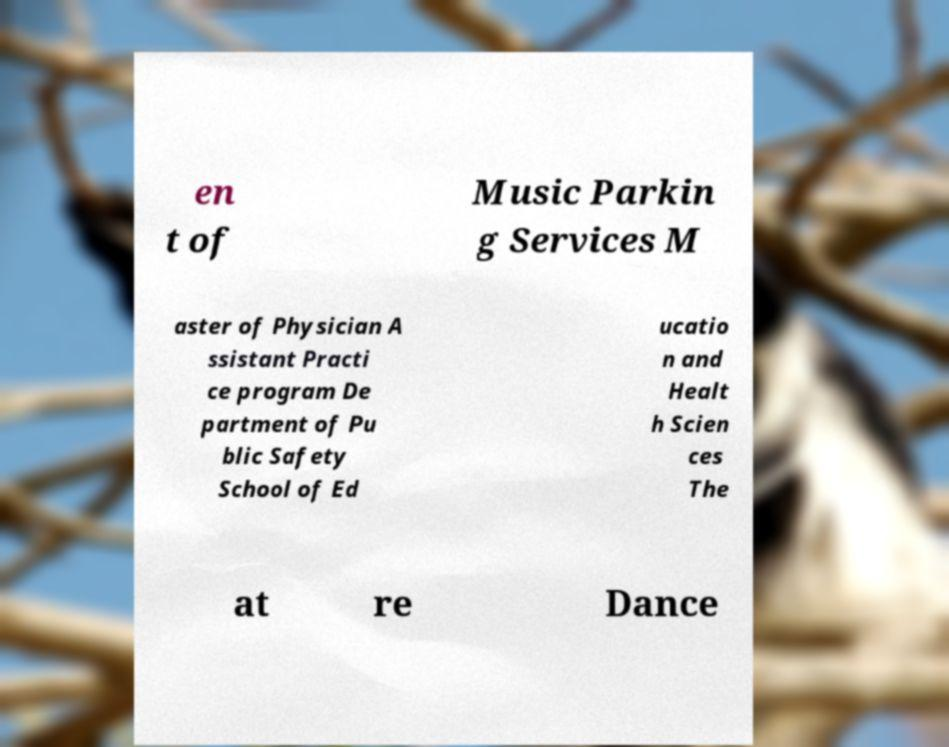Can you read and provide the text displayed in the image?This photo seems to have some interesting text. Can you extract and type it out for me? en t of Music Parkin g Services M aster of Physician A ssistant Practi ce program De partment of Pu blic Safety School of Ed ucatio n and Healt h Scien ces The at re Dance 